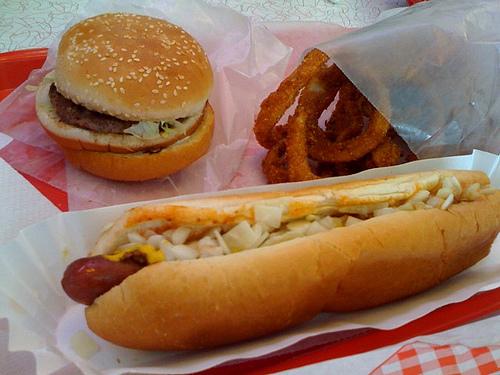Was this hot dog purchased from the stand in background?
Concise answer only. Yes. Does this hot dog have "the works"?
Keep it brief. Yes. What is in the bag next to the hot dog?
Concise answer only. Onion rings. Where are the onion rings?
Write a very short answer. Bag. What is used to cover the hot dog?
Be succinct. Onions. How many hot dogs are visible?
Give a very brief answer. 1. What is the food placed on?
Answer briefly. Paper. 